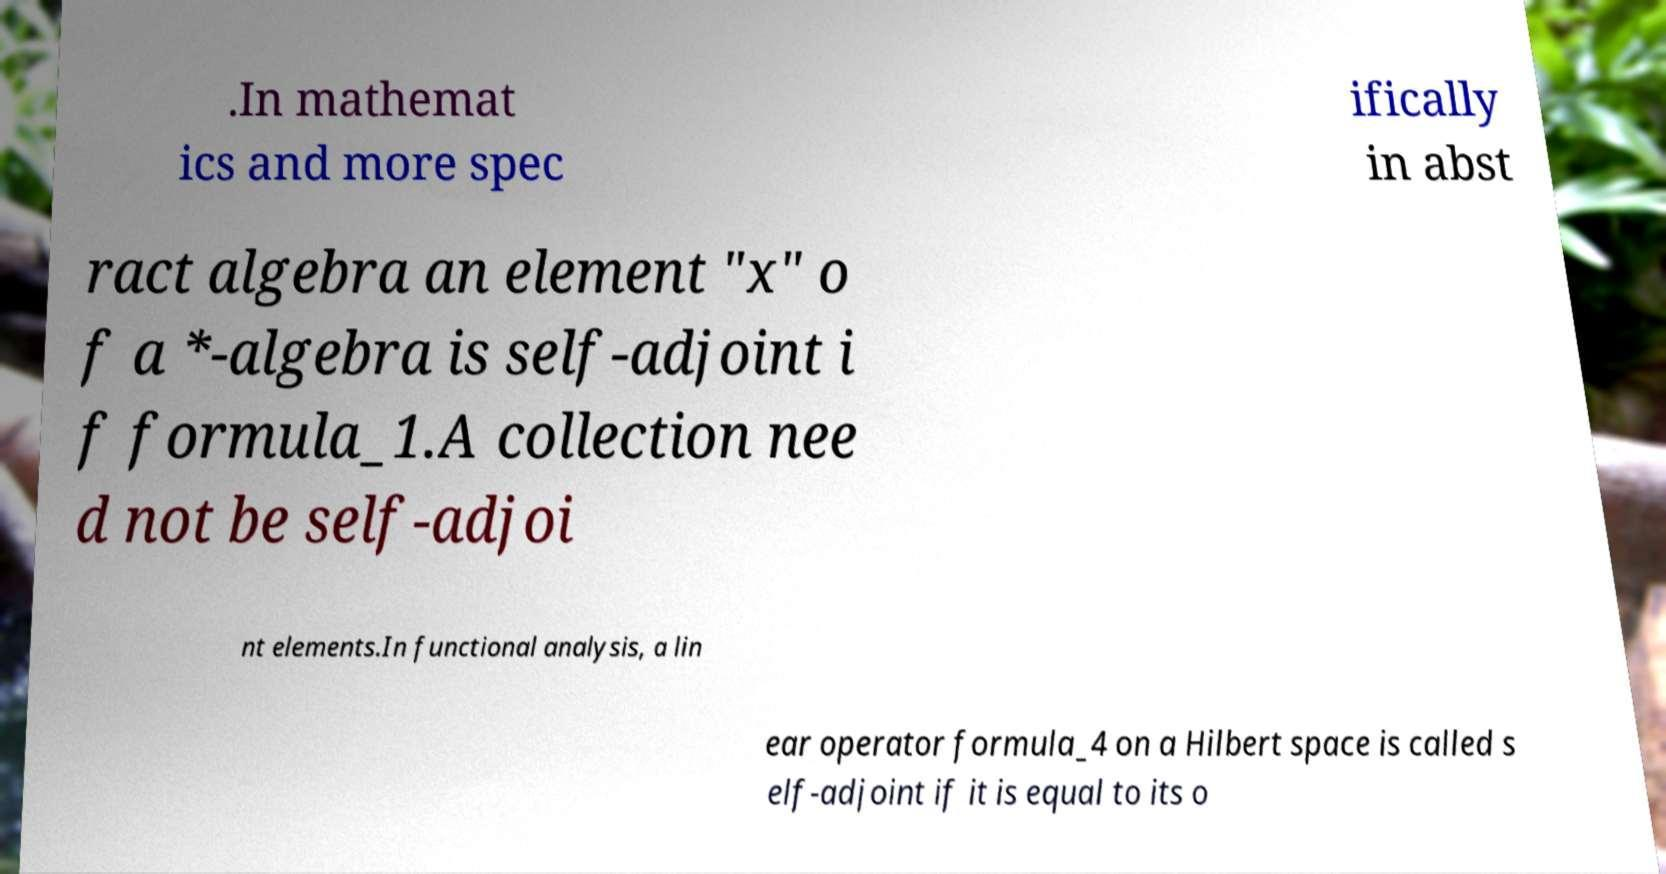What messages or text are displayed in this image? I need them in a readable, typed format. .In mathemat ics and more spec ifically in abst ract algebra an element "x" o f a *-algebra is self-adjoint i f formula_1.A collection nee d not be self-adjoi nt elements.In functional analysis, a lin ear operator formula_4 on a Hilbert space is called s elf-adjoint if it is equal to its o 